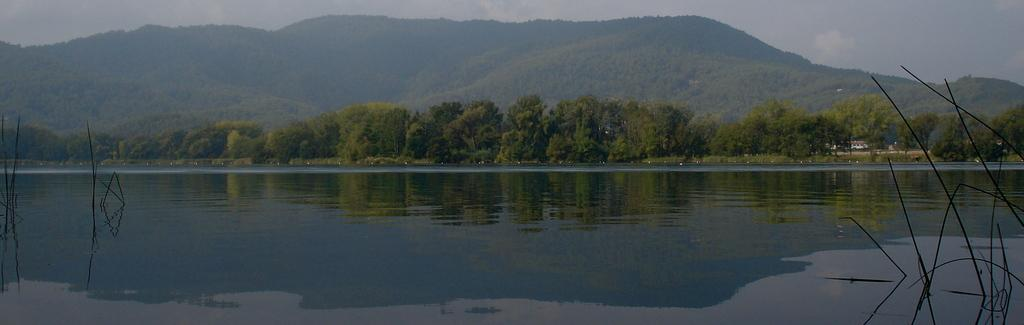What can be seen in the sky in the image? The sky is visible in the image, and clouds are present. What type of natural features can be seen in the image? Hills and trees are present in the image. What body of water is visible in the image? A river is visible in the image. How many pigs are hanging from the cobweb in the image? There are no pigs or cobwebs present in the image. 